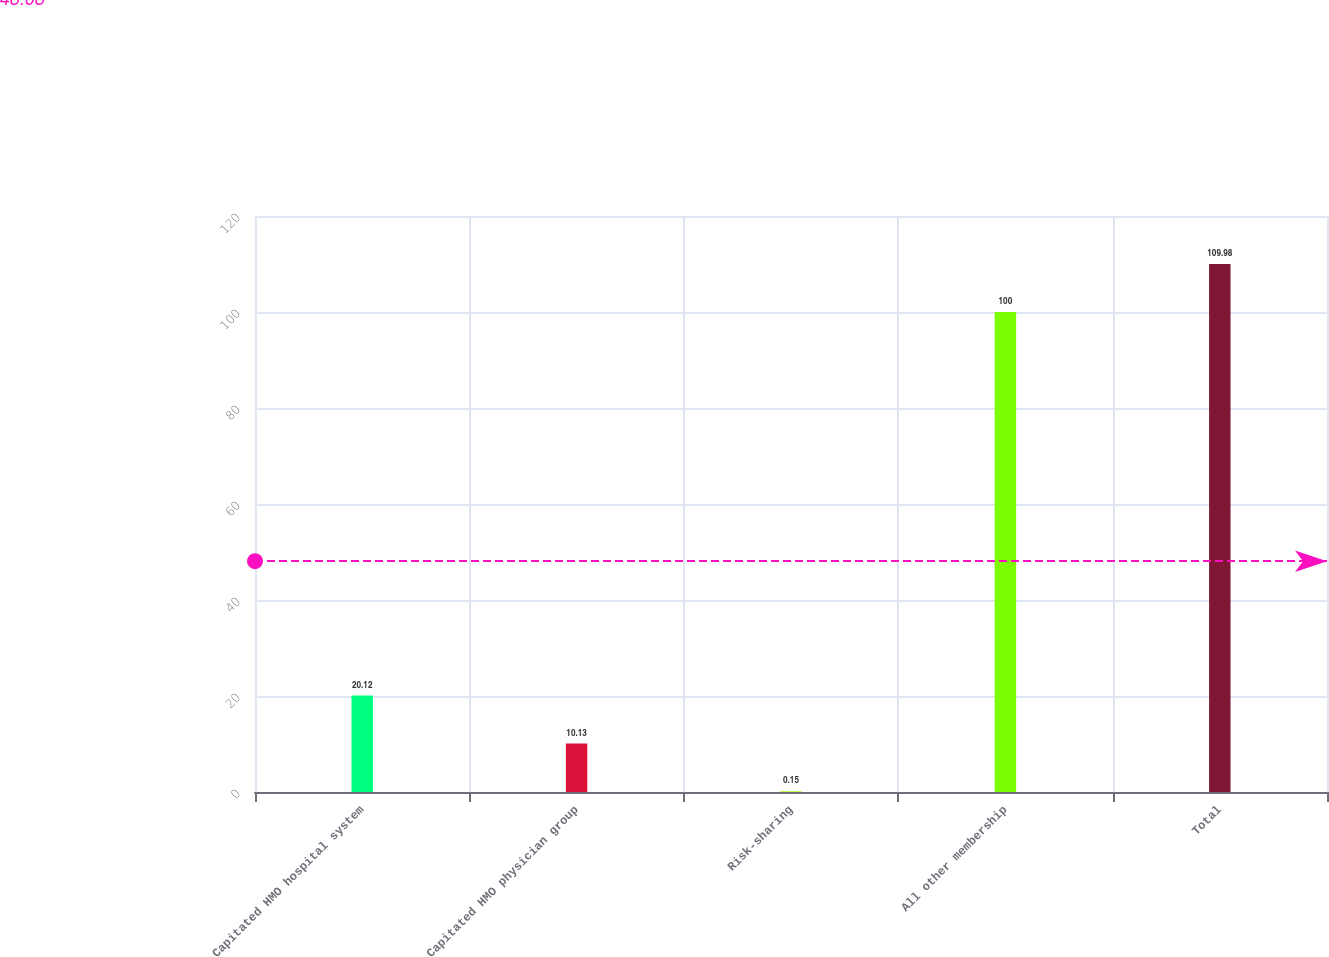Convert chart to OTSL. <chart><loc_0><loc_0><loc_500><loc_500><bar_chart><fcel>Capitated HMO hospital system<fcel>Capitated HMO physician group<fcel>Risk-sharing<fcel>All other membership<fcel>Total<nl><fcel>20.12<fcel>10.13<fcel>0.15<fcel>100<fcel>109.98<nl></chart> 